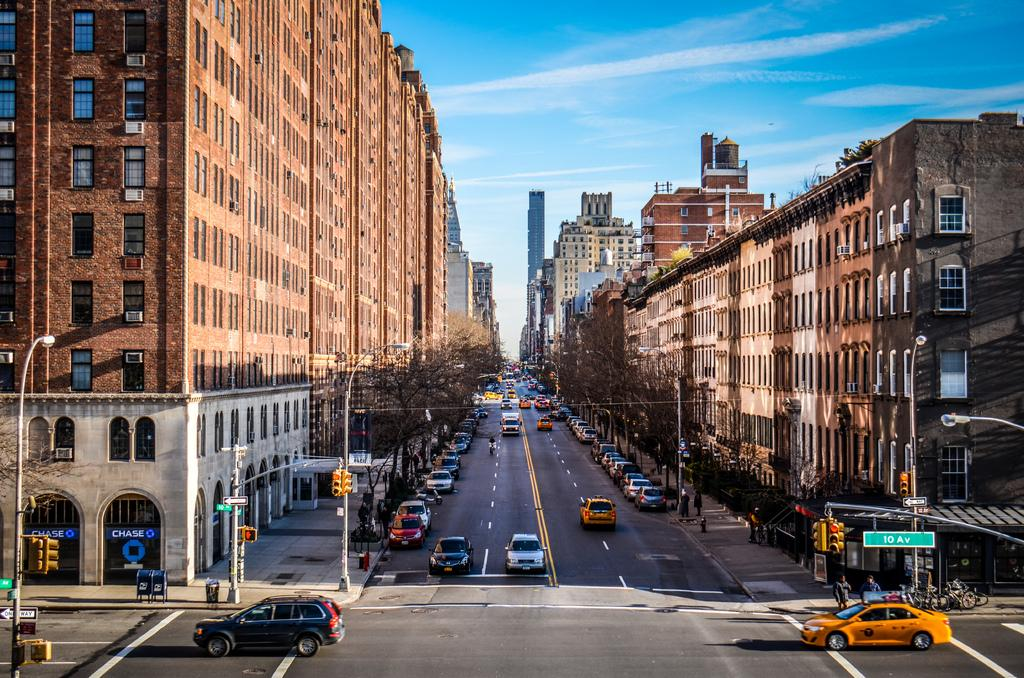<image>
Create a compact narrative representing the image presented. The street sign on this busy street says 10th avenue. 